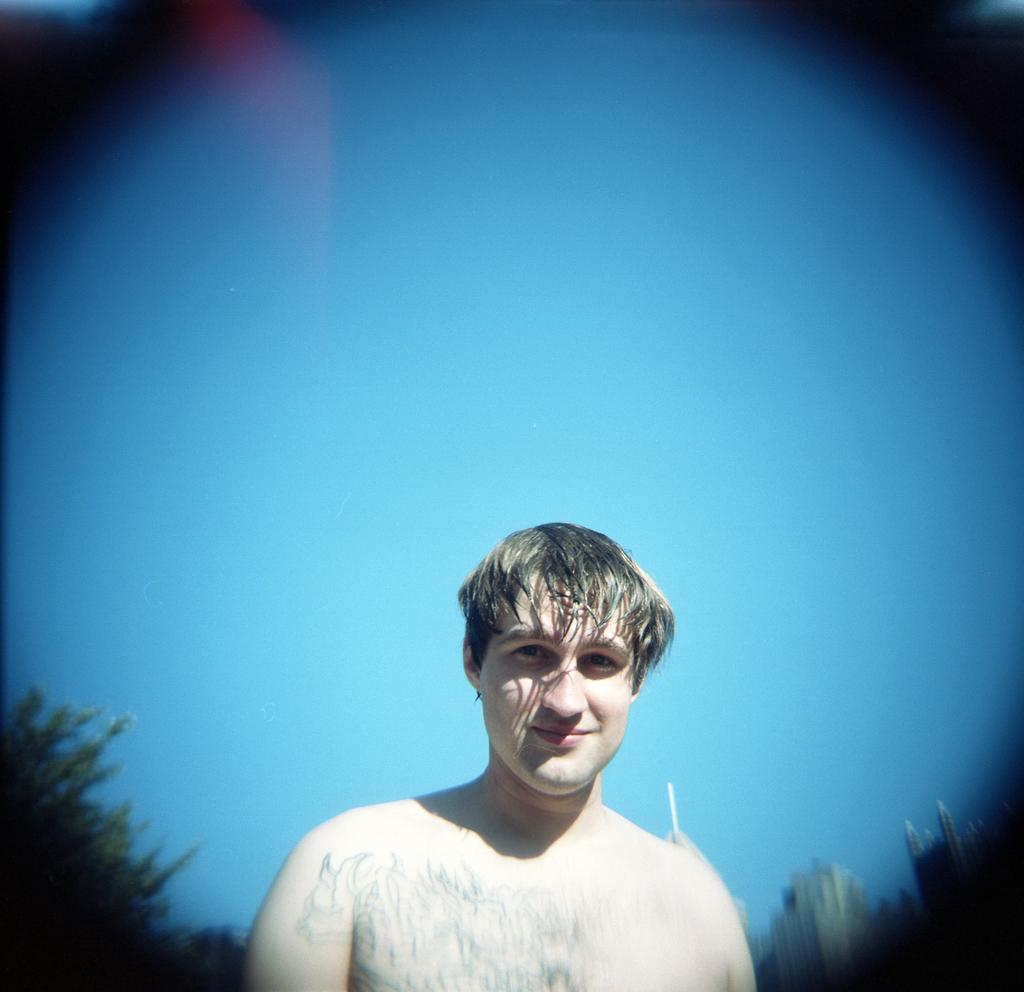Who is present in the image? There is a man in the picture. What can be observed on the man's body? The man has tattoos on his body. What is visible in the background of the image? There is a sky, buildings, and plants visible in the background of the image. What type of yam is being kicked in the image? There is no yam or kicking activity present in the image. What kind of stone is being used as a paperweight on the man's desk? There is no desk or stone visible in the image. 